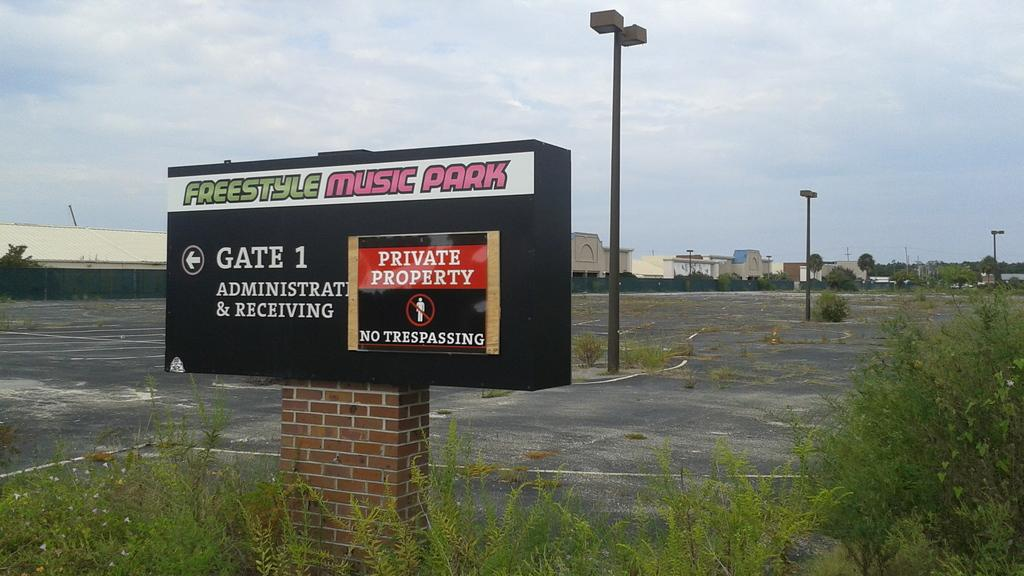<image>
Offer a succinct explanation of the picture presented. An empty parking lot with overgrown grass at gate 1 for the Freestyle Music Park is private property. 